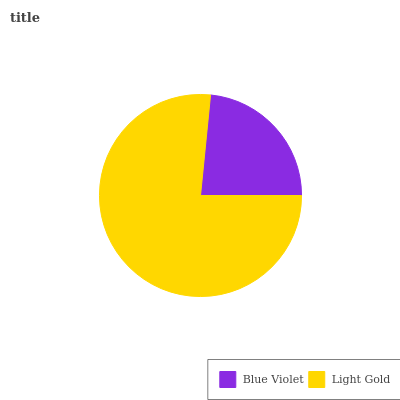Is Blue Violet the minimum?
Answer yes or no. Yes. Is Light Gold the maximum?
Answer yes or no. Yes. Is Light Gold the minimum?
Answer yes or no. No. Is Light Gold greater than Blue Violet?
Answer yes or no. Yes. Is Blue Violet less than Light Gold?
Answer yes or no. Yes. Is Blue Violet greater than Light Gold?
Answer yes or no. No. Is Light Gold less than Blue Violet?
Answer yes or no. No. Is Light Gold the high median?
Answer yes or no. Yes. Is Blue Violet the low median?
Answer yes or no. Yes. Is Blue Violet the high median?
Answer yes or no. No. Is Light Gold the low median?
Answer yes or no. No. 